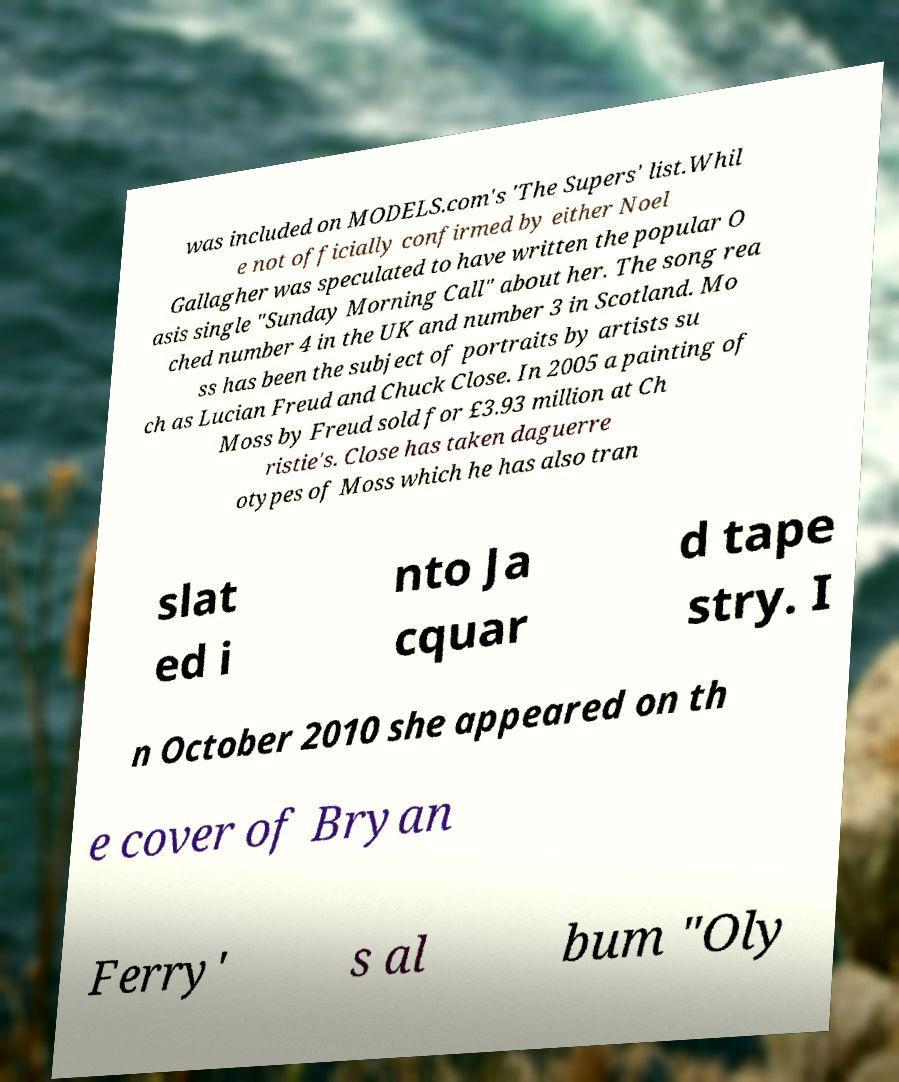For documentation purposes, I need the text within this image transcribed. Could you provide that? was included on MODELS.com's 'The Supers' list.Whil e not officially confirmed by either Noel Gallagher was speculated to have written the popular O asis single "Sunday Morning Call" about her. The song rea ched number 4 in the UK and number 3 in Scotland. Mo ss has been the subject of portraits by artists su ch as Lucian Freud and Chuck Close. In 2005 a painting of Moss by Freud sold for £3.93 million at Ch ristie's. Close has taken daguerre otypes of Moss which he has also tran slat ed i nto Ja cquar d tape stry. I n October 2010 she appeared on th e cover of Bryan Ferry' s al bum "Oly 